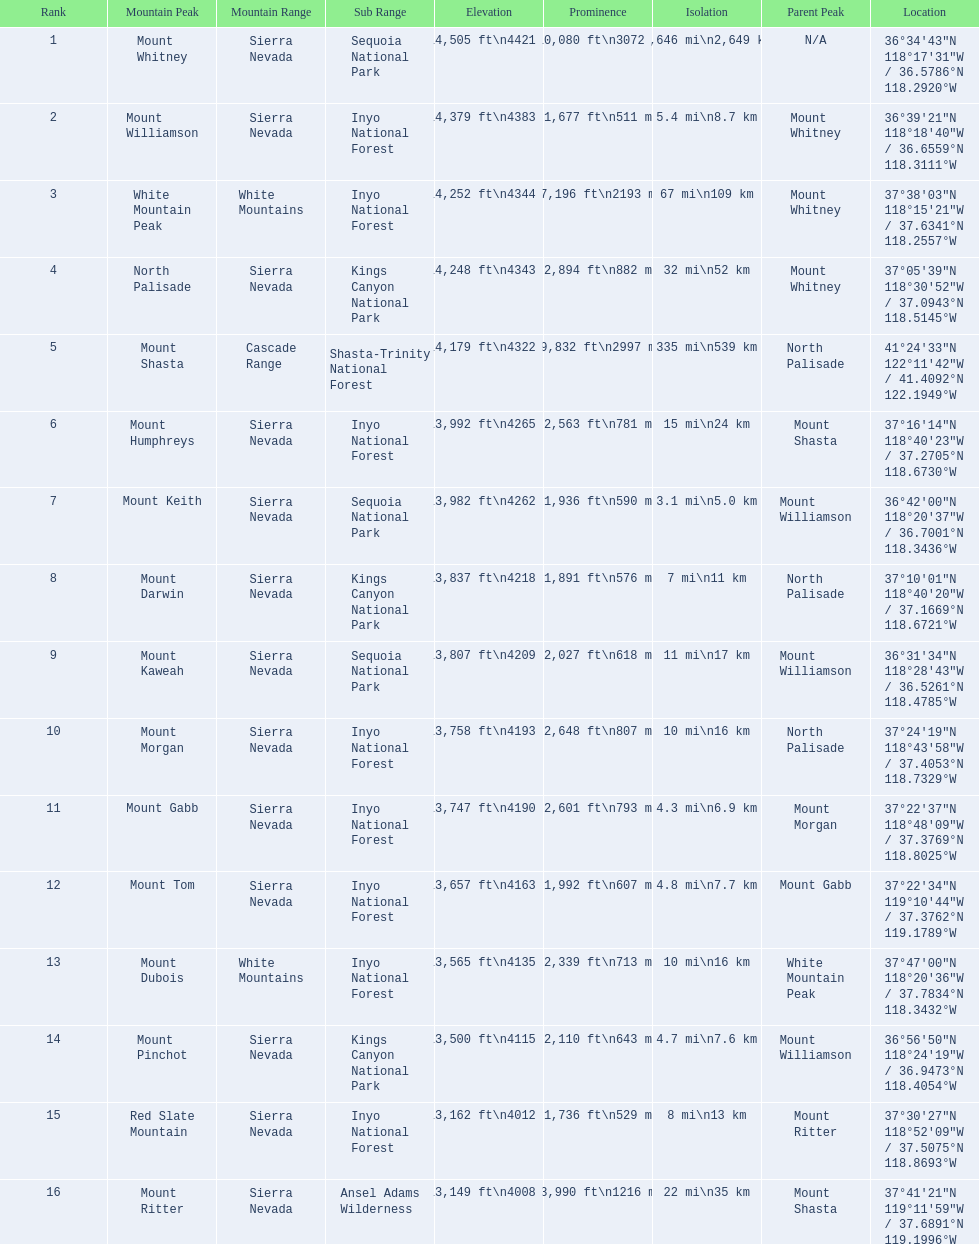Which mountain peaks have a prominence over 9,000 ft? Mount Whitney, Mount Shasta. Of those, which one has the the highest prominence? Mount Whitney. 